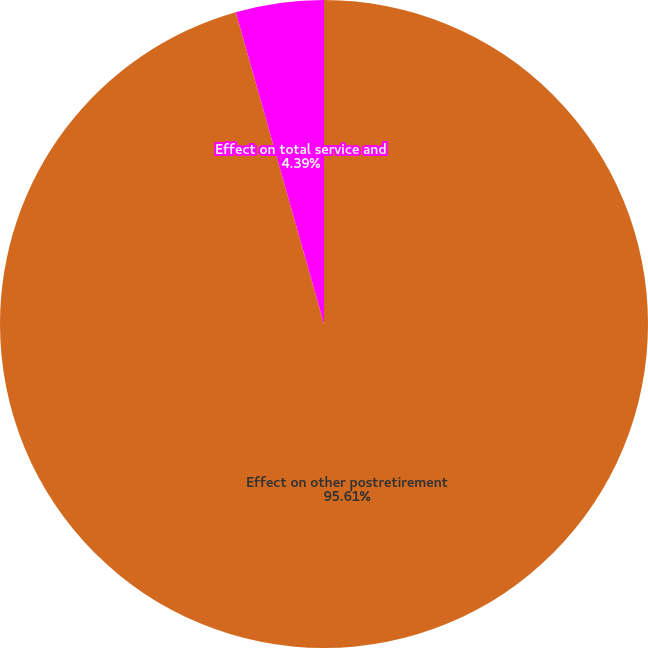Convert chart to OTSL. <chart><loc_0><loc_0><loc_500><loc_500><pie_chart><fcel>Effect on other postretirement<fcel>Effect on total service and<nl><fcel>95.61%<fcel>4.39%<nl></chart> 